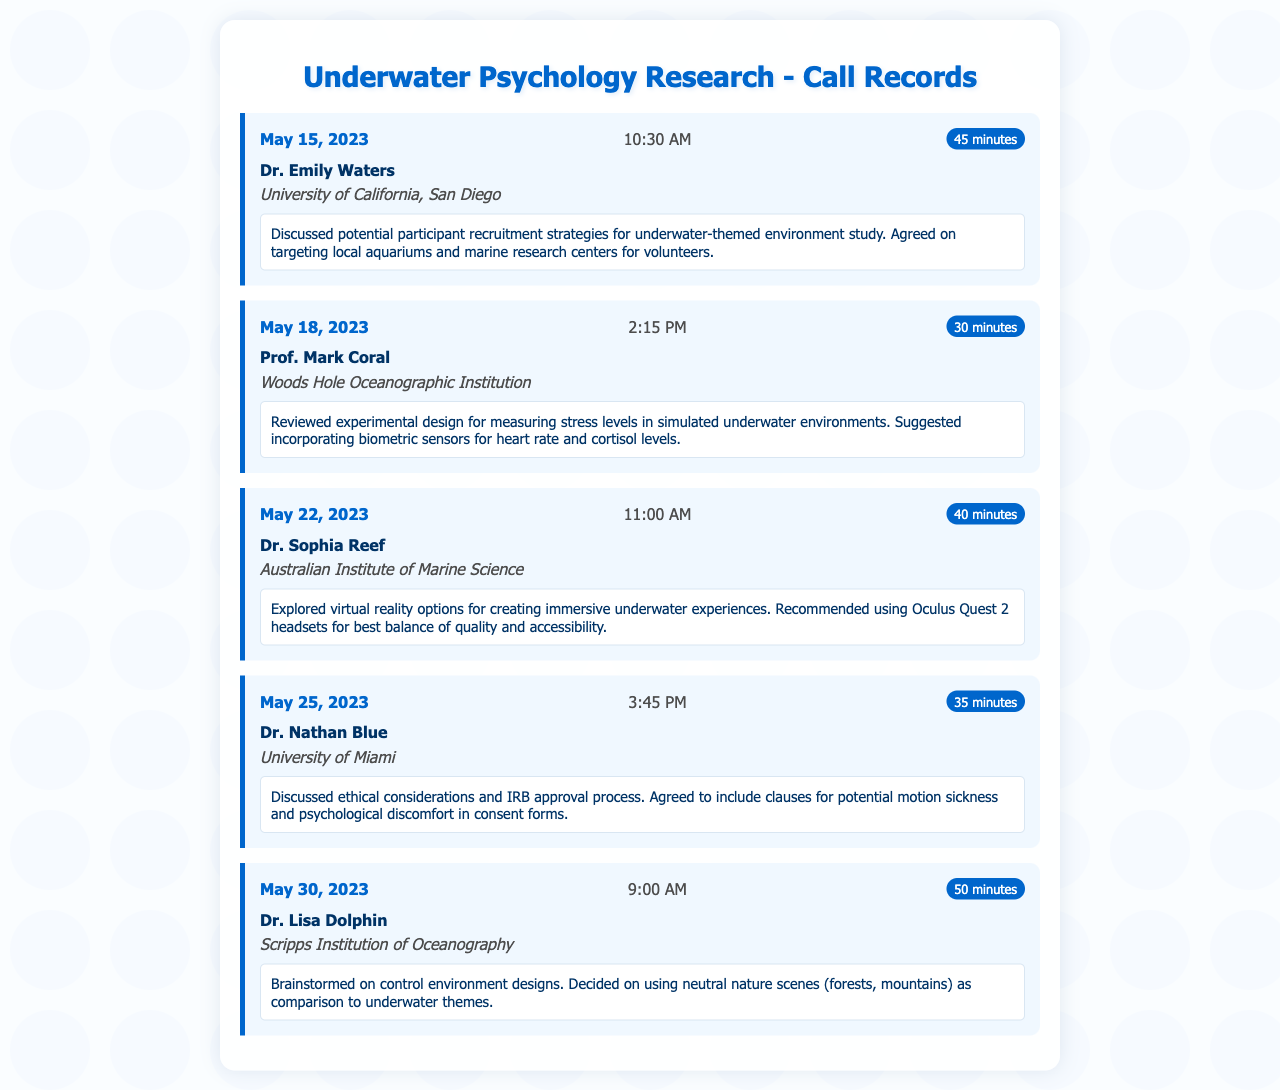What is the date of the first call? The first call is recorded on May 15, 2023.
Answer: May 15, 2023 Who is the contact for the call on May 18, 2023? The contact for the call on this date is Prof. Mark Coral.
Answer: Prof. Mark Coral How long was the call with Dr. Nathan Blue? The duration of this call was 35 minutes.
Answer: 35 minutes What was discussed in the call with Dr. Lisa Dolphin? The call focused on designing control environments for the study.
Answer: Control environment designs What technology did Dr. Sophia Reef recommend for creating immersive experiences? Dr. Reef suggested using Oculus Quest 2 headsets.
Answer: Oculus Quest 2 headsets What was a key ethical consideration mentioned in the call with Dr. Nathan Blue? The discussion included clauses for potential motion sickness.
Answer: Motion sickness Which institution does Dr. Emily Waters belong to? Dr. Waters is affiliated with the University of California, San Diego.
Answer: University of California, San Diego What are the stress levels being measured in the study? The study aims to measure heart rate and cortisol levels.
Answer: Heart rate and cortisol levels 